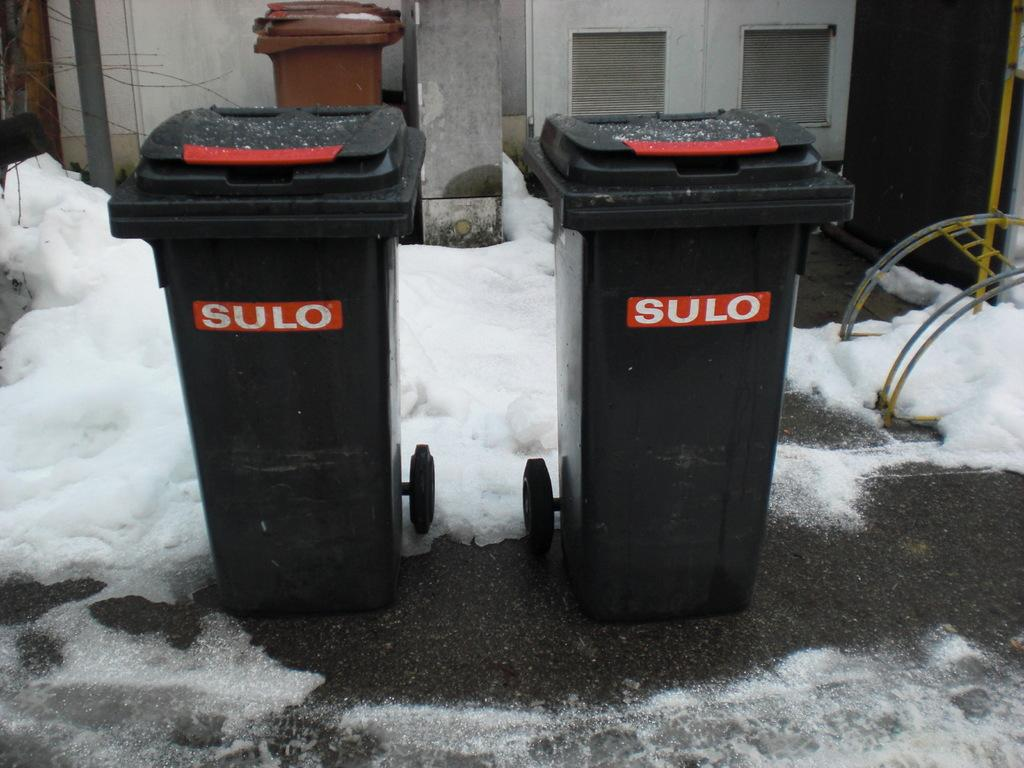Provide a one-sentence caption for the provided image. Two black garbage cans that says SULO on it. 